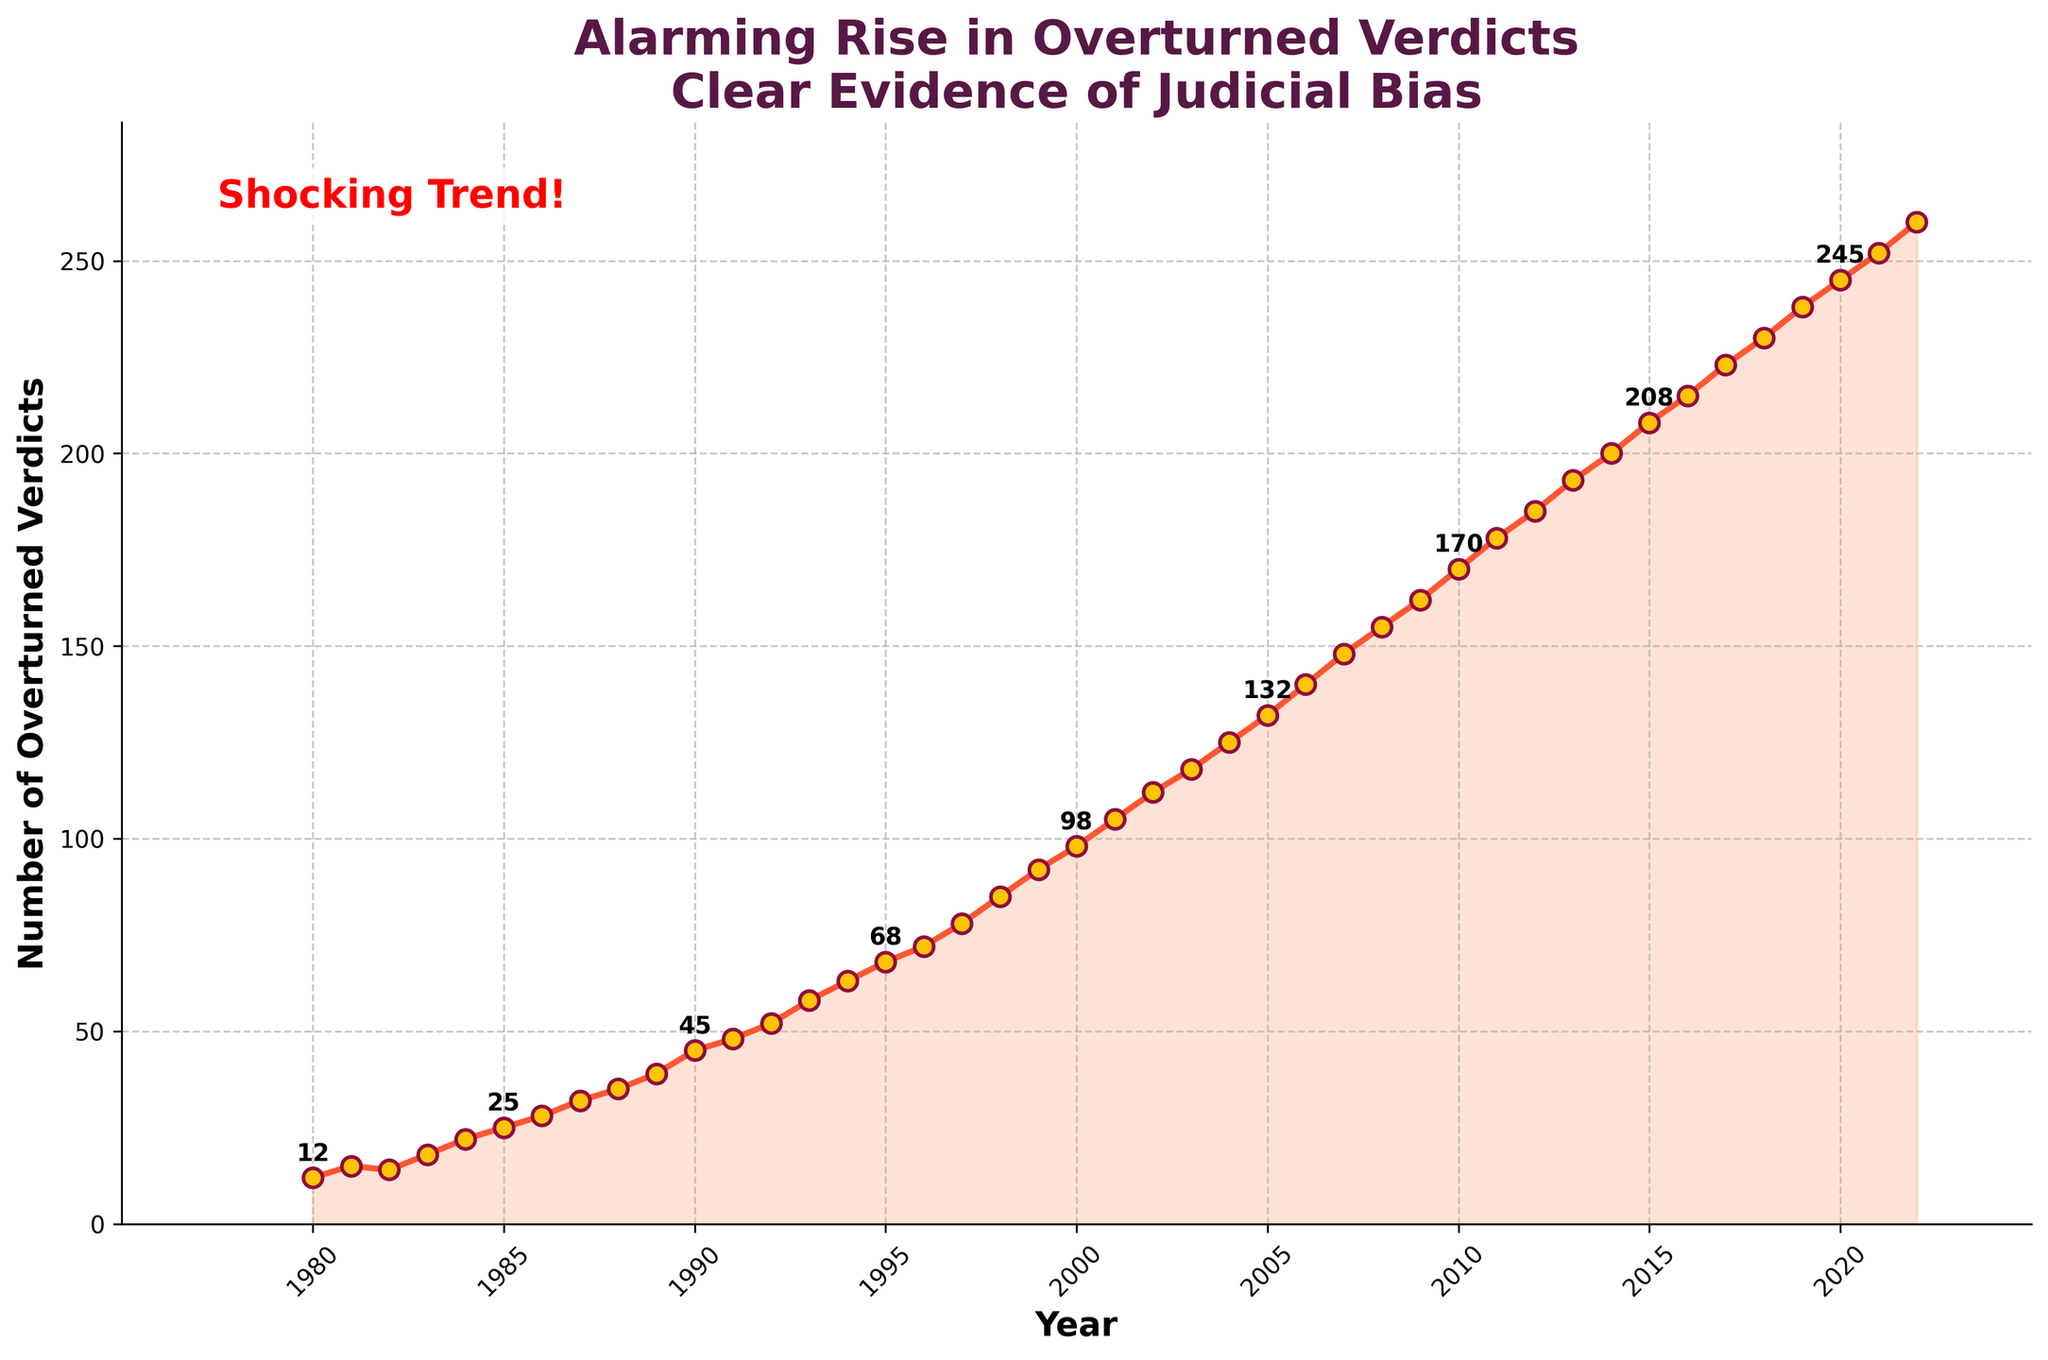Which year had the highest number of overturned verdicts? The chart shows that the number of overturned verdicts continuously rises each year, with the highest count appearing in the most recent year, 2022, with 260 overturned verdicts.
Answer: 2022 What's the difference in the number of overturned verdicts between 1980 and 2022? In 1980, there were 12 overturned verdicts, and in 2022, there were 260. The difference is calculated as 260 - 12.
Answer: 248 How does the number of overturned verdicts in 2000 compare to 2020? In 2000, there were 98 overturned verdicts, while in 2020, there were 245. This means that by 2020, the figure increased substantially.
Answer: 2020 had more overturned verdicts than 2000 What is the average number of overturned verdicts over the entire period shown? First, sum up all the yearly overturned verdict counts from 1980 to 2022, then divide by the number of years. So, the average is (12 + 15 + 14 + ... + 245 + 252 + 260)/43.
Answer: 125.26 (rounded to 2 decimal places) Which five-year period saw the most significant increase in overturned verdicts? Looking at the increments between five-year periods, 2015 to 2020 (208 to 245), an increase of 37, seems to be the period with the most significant rise.
Answer: 2015 to 2020 Is there any year where the number of overturned verdicts decreased compared to the previous year? Observing the chart, each year shows an increase in the number of overturned verdicts, indicating there wasn't a decrease in any year.
Answer: No What visual attributes highlight the alarming trend in overturned verdicts? The red line with markers and the filled area underneath visually reinforce the rising trend, along with annotated data points and highlighted text "Shocking Trend!" to emphasize the focus.
Answer: Red line with markers, filled area, annotated points, emphasized text How much did the number of overturned verdicts increase from the year just before a labeled point (e.g., 1989) to another labeled point (e.g., 1994)? In 1989, the count was 39, and by 1994 it was 63. The increase is calculated as 63 - 39.
Answer: 24 